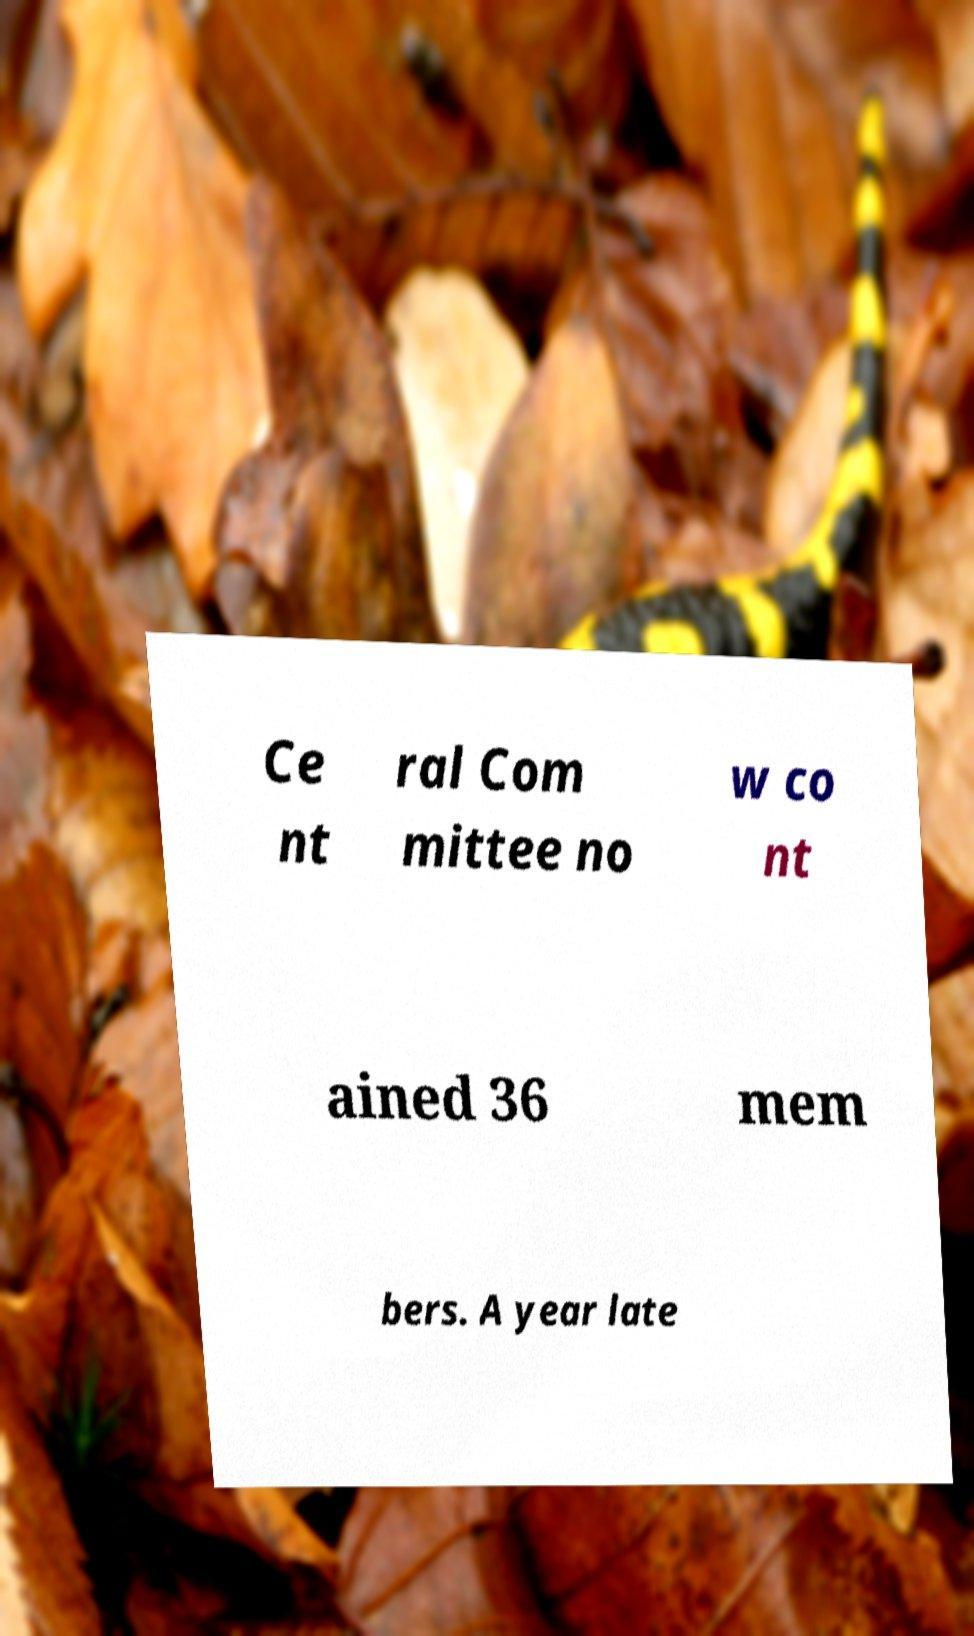Please read and relay the text visible in this image. What does it say? Ce nt ral Com mittee no w co nt ained 36 mem bers. A year late 